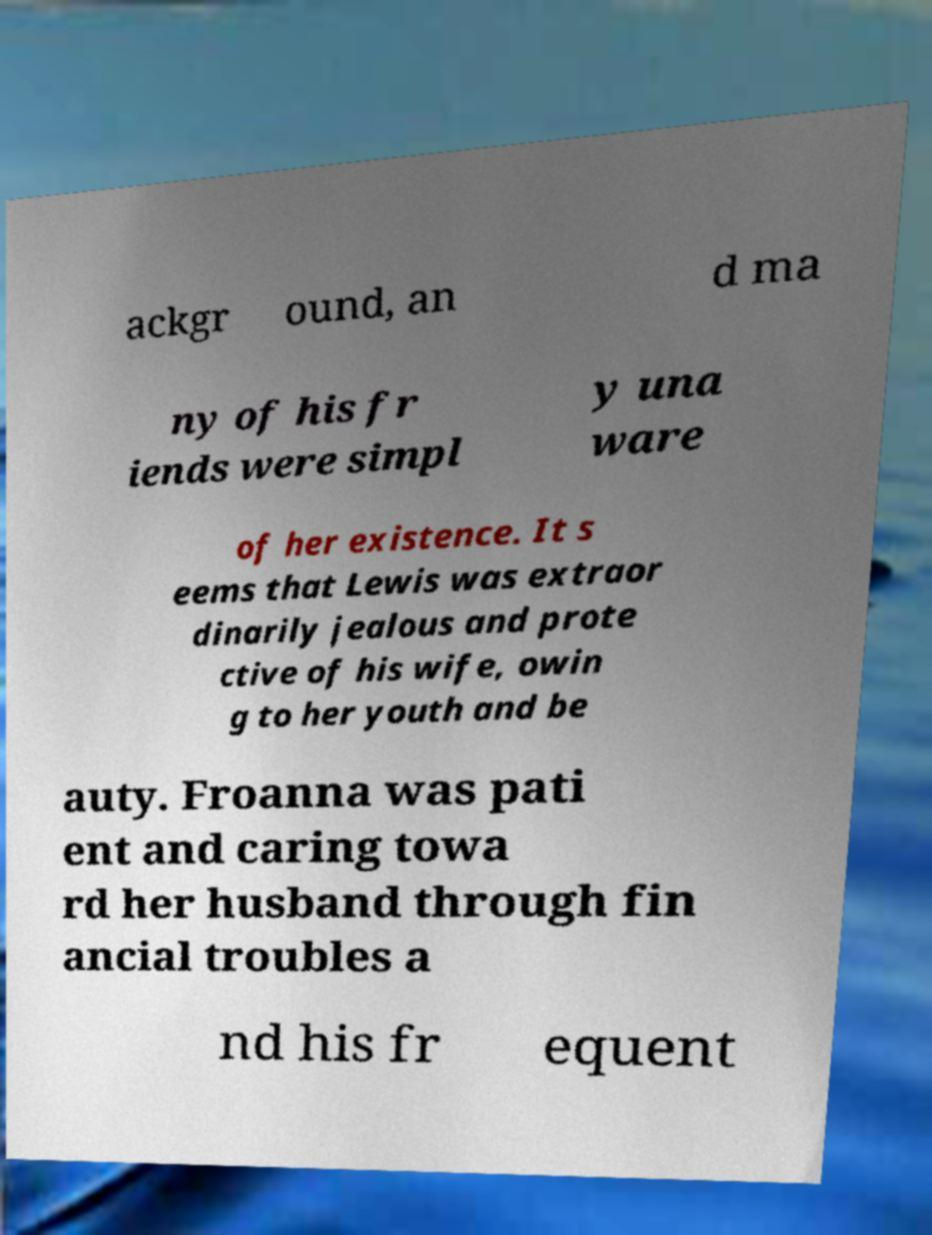There's text embedded in this image that I need extracted. Can you transcribe it verbatim? ackgr ound, an d ma ny of his fr iends were simpl y una ware of her existence. It s eems that Lewis was extraor dinarily jealous and prote ctive of his wife, owin g to her youth and be auty. Froanna was pati ent and caring towa rd her husband through fin ancial troubles a nd his fr equent 